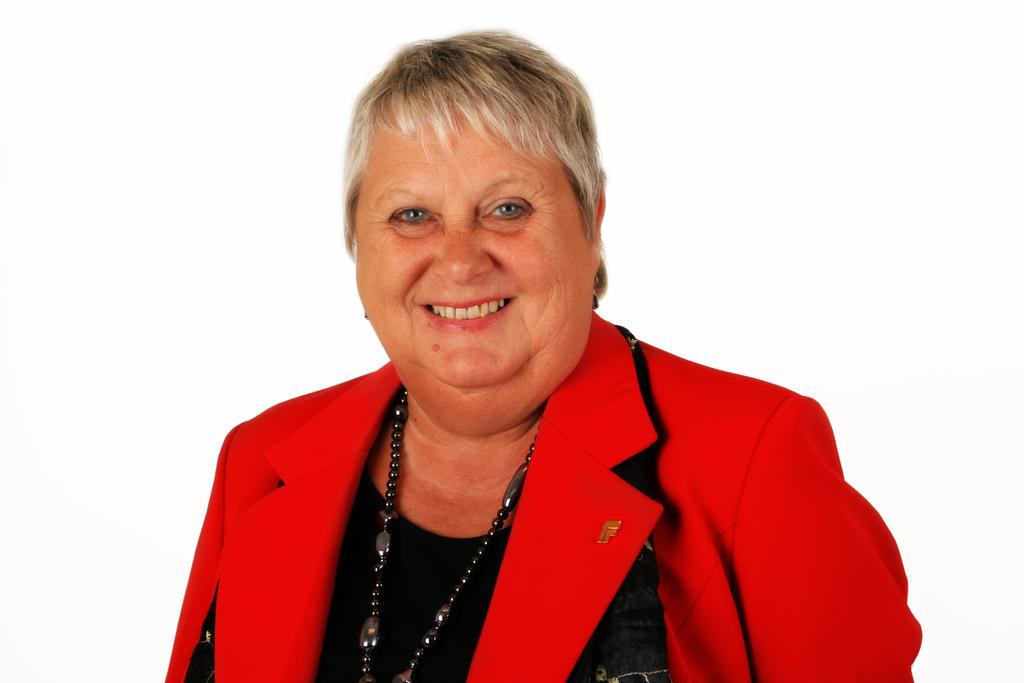Who is present in the image? There is a woman in the image. What is the woman doing in the image? The woman is smiling in the image. What is the woman wearing in the image? The woman is wearing a red and black color dress and a black chain in the image. What is the color of the background in the image? The background of the image is white in color. What type of humor can be seen in the woman's coat in the image? There is no coat present in the image, and therefore no humor can be seen in it. 